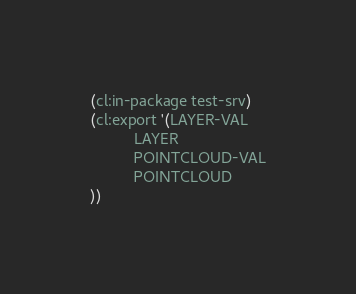<code> <loc_0><loc_0><loc_500><loc_500><_Lisp_>(cl:in-package test-srv)
(cl:export '(LAYER-VAL
          LAYER
          POINTCLOUD-VAL
          POINTCLOUD
))</code> 